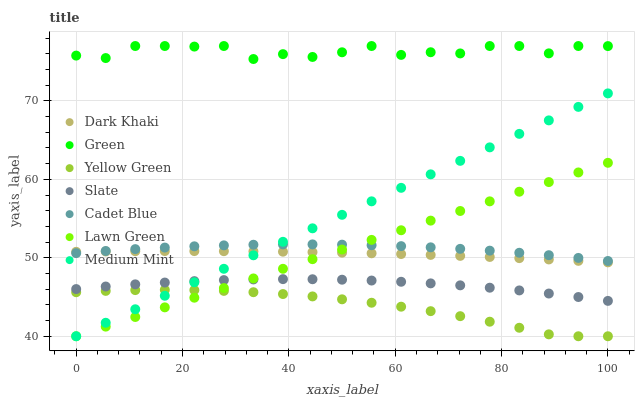Does Yellow Green have the minimum area under the curve?
Answer yes or no. Yes. Does Green have the maximum area under the curve?
Answer yes or no. Yes. Does Lawn Green have the minimum area under the curve?
Answer yes or no. No. Does Lawn Green have the maximum area under the curve?
Answer yes or no. No. Is Lawn Green the smoothest?
Answer yes or no. Yes. Is Green the roughest?
Answer yes or no. Yes. Is Cadet Blue the smoothest?
Answer yes or no. No. Is Cadet Blue the roughest?
Answer yes or no. No. Does Medium Mint have the lowest value?
Answer yes or no. Yes. Does Cadet Blue have the lowest value?
Answer yes or no. No. Does Green have the highest value?
Answer yes or no. Yes. Does Lawn Green have the highest value?
Answer yes or no. No. Is Slate less than Cadet Blue?
Answer yes or no. Yes. Is Green greater than Slate?
Answer yes or no. Yes. Does Lawn Green intersect Dark Khaki?
Answer yes or no. Yes. Is Lawn Green less than Dark Khaki?
Answer yes or no. No. Is Lawn Green greater than Dark Khaki?
Answer yes or no. No. Does Slate intersect Cadet Blue?
Answer yes or no. No. 